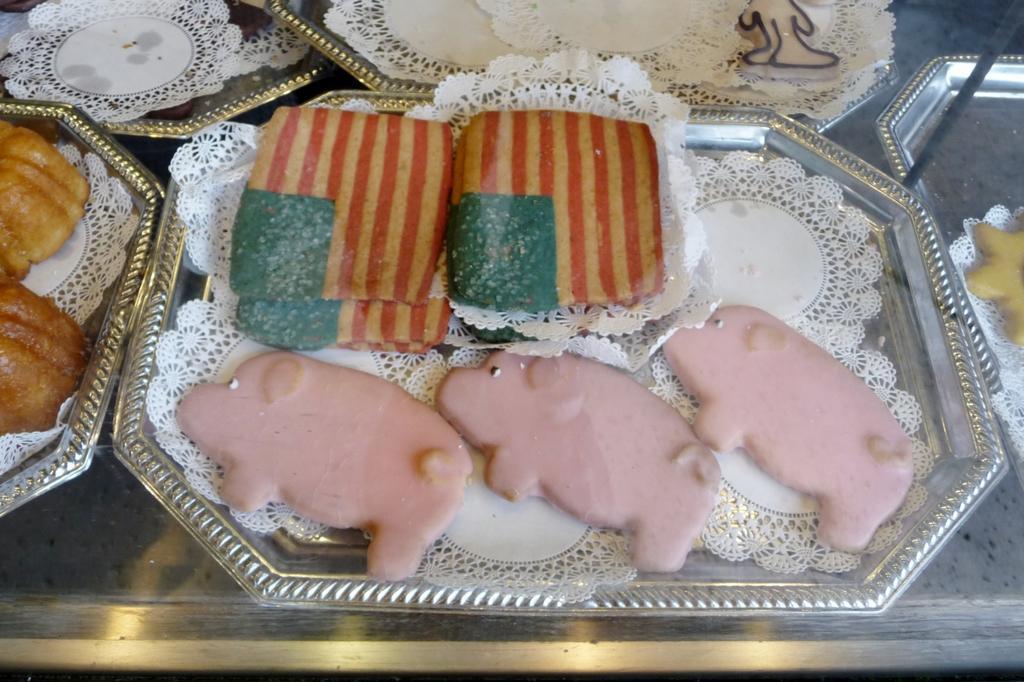Can you describe this image briefly? This image consists of five trays, plates in which food items are kept may be on the table. This image is taken may be in a room. 